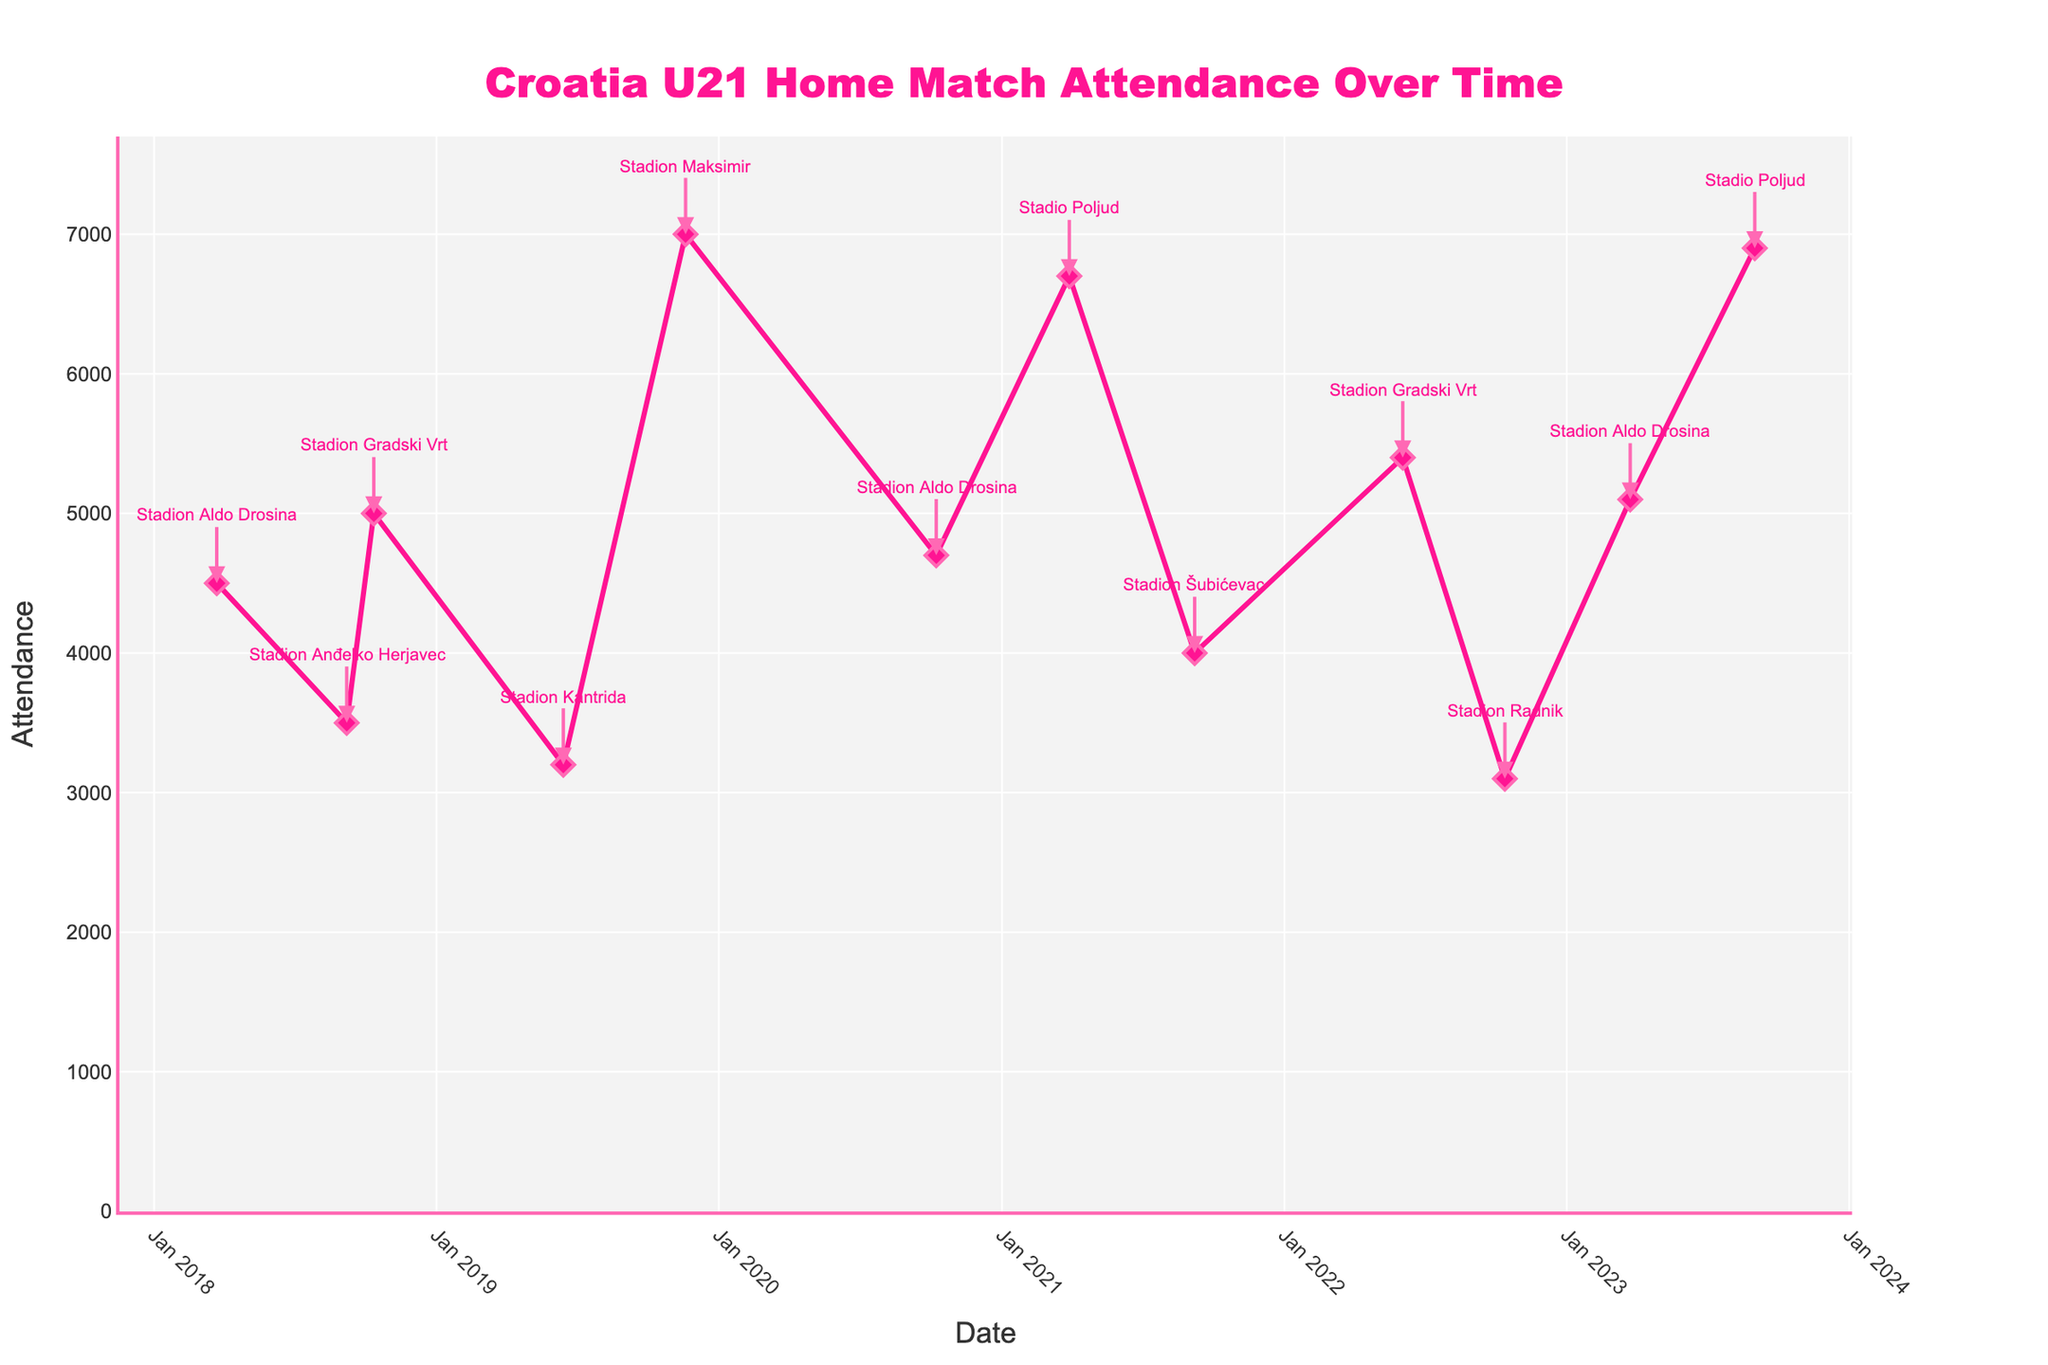How many matches are shown in the time series plot? Count each data point or marker in the plot. There are 12 dates listed, which indicates 12 matches.
Answer: 12 What is the maximum attendance shown on the plot? Find the highest point on the y-axis and match it with the corresponding value. The highest attendance is seen in Zagreb on 2019-11-19 with 7000 fans.
Answer: 7000 Which stadium had the lowest attendance, and what was the attendance figure? Look for the lowest data point on the y-axis and follow it to its annotation. The lowest attendance was at Stadion Radnik in Velika Gorica on 2022-10-13 with 3100 fans.
Answer: Stadion Radnik, 3100 How did the attendance trend from March 2018 to September 2023? Review the plot from the start to the end dates to understand the pattern. The attendance shows fluctuations with some peaks, notably increasing around late 2019 but decreasing towards the mid-2022 year, before rising again in 2023.
Answer: Fluctuated, with peaks in late 2019 and 2023 Which date had the highest attendance, and how much was it? Find the highest point on the plot and note the corresponding date and attendance value. The highest attendance was on 2019-11-19 with 7000 fans.
Answer: 2019-11-19, 7000 What is the average attendance of all the matches played? Sum up all attendance numbers and divide by the number of data points (12 matches). The total attendance is 52200, so the average is 52200 / 12 = 4350.
Answer: 4350 Which city hosted the most matches, and how many? Identify the city with the most annotations in the plot. Pula hosted the most matches, with three dates shown (2018-03-23, 2020-10-08, 2023-03-24).
Answer: Pula, 3 Was there any increase in attendance in matches played at Stadion Aldo Drosina over time? Look specifically at the points annotated with "Stadion Aldo Drosina". The attendances were 4500, 4700, and 5100 over three dates.
Answer: Yes What was the range of attendances observed in the matches? Identify the highest and lowest values on the y-axis, then find the difference. The highest is 7000, and the lowest is 3100, so the range is 7000 - 3100 = 3900.
Answer: 3900 In which year did Croatia U21 see the highest total attendance for their home matches based on the data? Sum up the attendances for each year and identify the year with the highest total. 2019 had the highest total, adding up to 10200 (3200 (Jun) + 7000 (Nov)).
Answer: 2019 